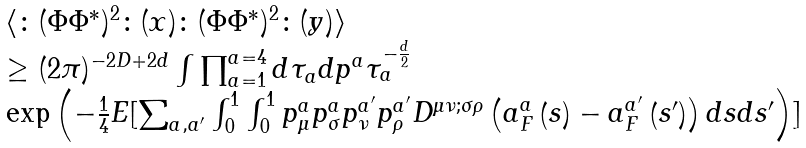<formula> <loc_0><loc_0><loc_500><loc_500>\begin{array} { l } { { \langle \colon ( \Phi \Phi ^ { * } ) ^ { 2 } \colon ( x ) \colon ( \Phi \Phi ^ { * } ) ^ { 2 } \colon ( y ) \rangle } } \\ { { \geq ( 2 \pi ) ^ { - 2 D + 2 d } \int \prod _ { a = 1 } ^ { a = 4 } d \tau _ { a } d { p } ^ { a } \tau _ { a } ^ { - \frac { d } { 2 } } } } \\ { { \exp \left ( - \frac { 1 } { 4 } E [ \sum _ { a , a ^ { \prime } } \int _ { 0 } ^ { 1 } \int _ { 0 } ^ { 1 } p _ { \mu } ^ { a } p _ { \sigma } ^ { a } p _ { \nu } ^ { a ^ { \prime } } p _ { \rho } ^ { a ^ { \prime } } D ^ { \mu \nu ; \sigma \rho } \left ( { a } _ { F } ^ { a } \left ( s \right ) - { a } _ { F } ^ { a ^ { \prime } } \left ( s ^ { \prime } \right ) \right ) d s d s ^ { \prime } \right ) ] } } \end{array}</formula> 